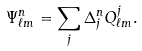<formula> <loc_0><loc_0><loc_500><loc_500>\Psi ^ { n } _ { \ell m } = \sum _ { j } \Delta ^ { n } _ { j } Q ^ { j } _ { \ell m } .</formula> 